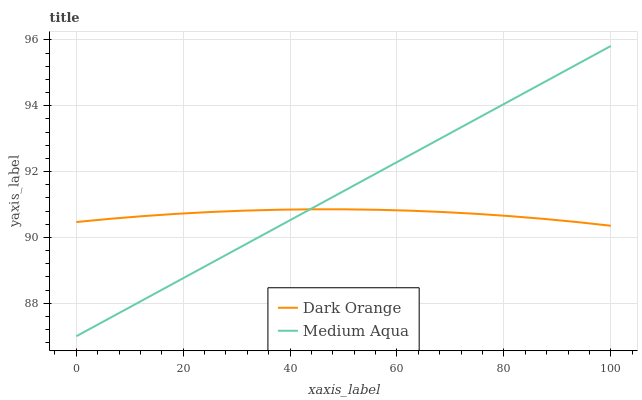Does Dark Orange have the minimum area under the curve?
Answer yes or no. Yes. Does Medium Aqua have the maximum area under the curve?
Answer yes or no. Yes. Does Medium Aqua have the minimum area under the curve?
Answer yes or no. No. Is Medium Aqua the smoothest?
Answer yes or no. Yes. Is Dark Orange the roughest?
Answer yes or no. Yes. Is Medium Aqua the roughest?
Answer yes or no. No. Does Medium Aqua have the highest value?
Answer yes or no. Yes. Does Dark Orange intersect Medium Aqua?
Answer yes or no. Yes. Is Dark Orange less than Medium Aqua?
Answer yes or no. No. Is Dark Orange greater than Medium Aqua?
Answer yes or no. No. 